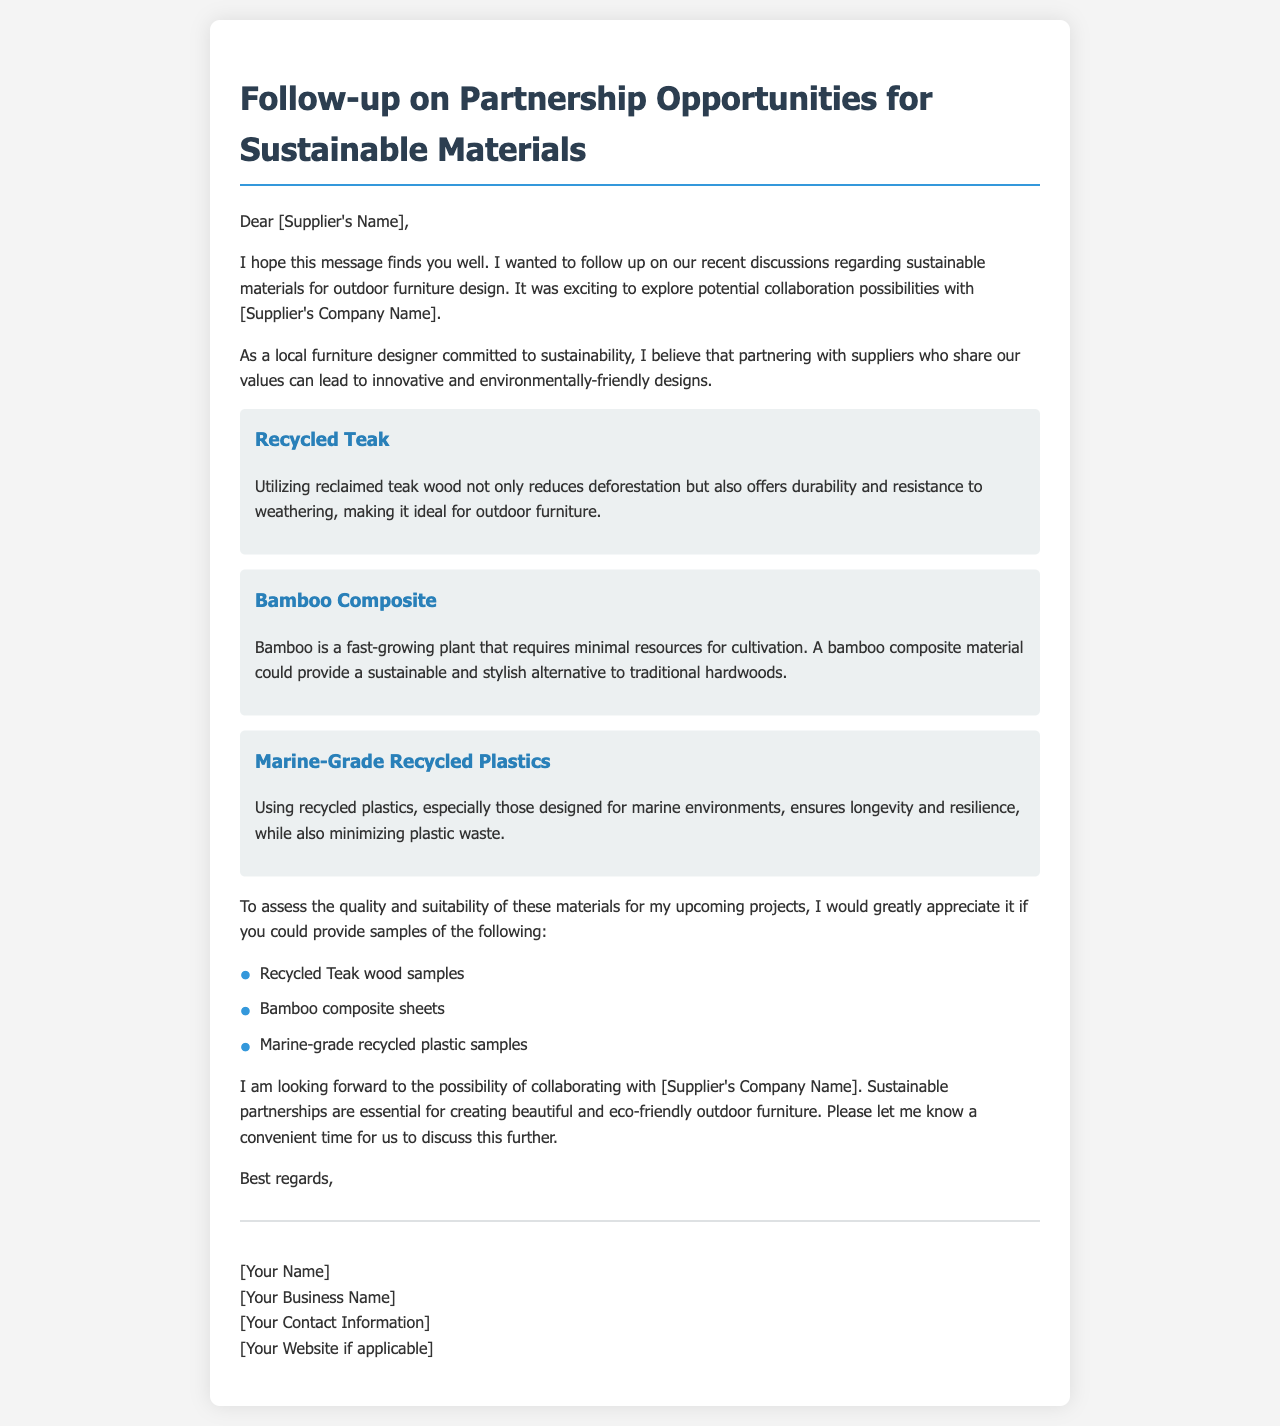What is the title of the document? The title of the document is clearly stated at the top of the rendered letter.
Answer: Follow-up on Partnership Opportunities for Sustainable Materials Who is the intended recipient of the letter? The intended recipient's name is addressed at the beginning of the letter.
Answer: [Supplier's Name] What type of materials is the letter focused on? The letter discusses specific types of materials intended for outdoor furniture design.
Answer: Sustainable materials Name one material mentioned in the document. One material discussed in the letter is listed in the sections describing potential sustainable options.
Answer: Recycled Teak What is the purpose of requesting samples? The purpose of requesting samples is to assess the quality and suitability for upcoming projects.
Answer: Assess quality and suitability How many types of material samples are requested in the letter? The document provides a list of material samples requested by the sender.
Answer: Three What does the sender identify as essential for creating eco-friendly furniture? The sender highlights a specific collaboration theme relevant to sustainability in their projects.
Answer: Sustainable partnerships What is the sender's professional commitment? The sender expresses a commitment to a specific practice in their furniture design work.
Answer: Sustainability What is included at the end of the letter? The ending portion of a business letter typically includes specific information about the sender.
Answer: Signature with name, business name, and contact information 